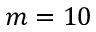<formula> <loc_0><loc_0><loc_500><loc_500>m = 1 0</formula> 